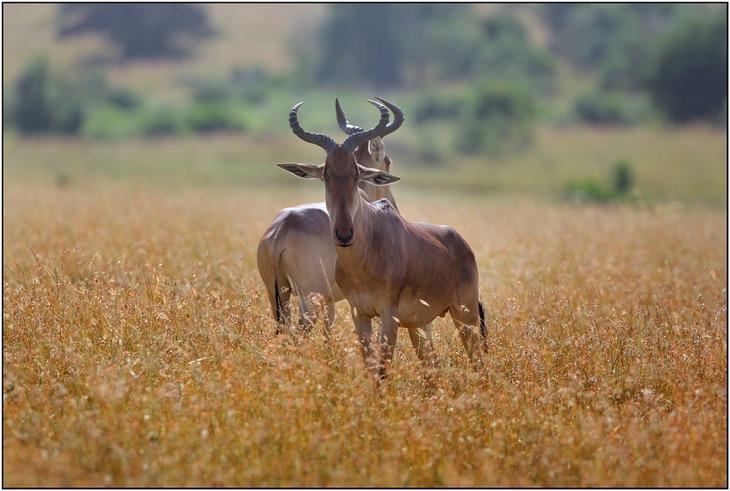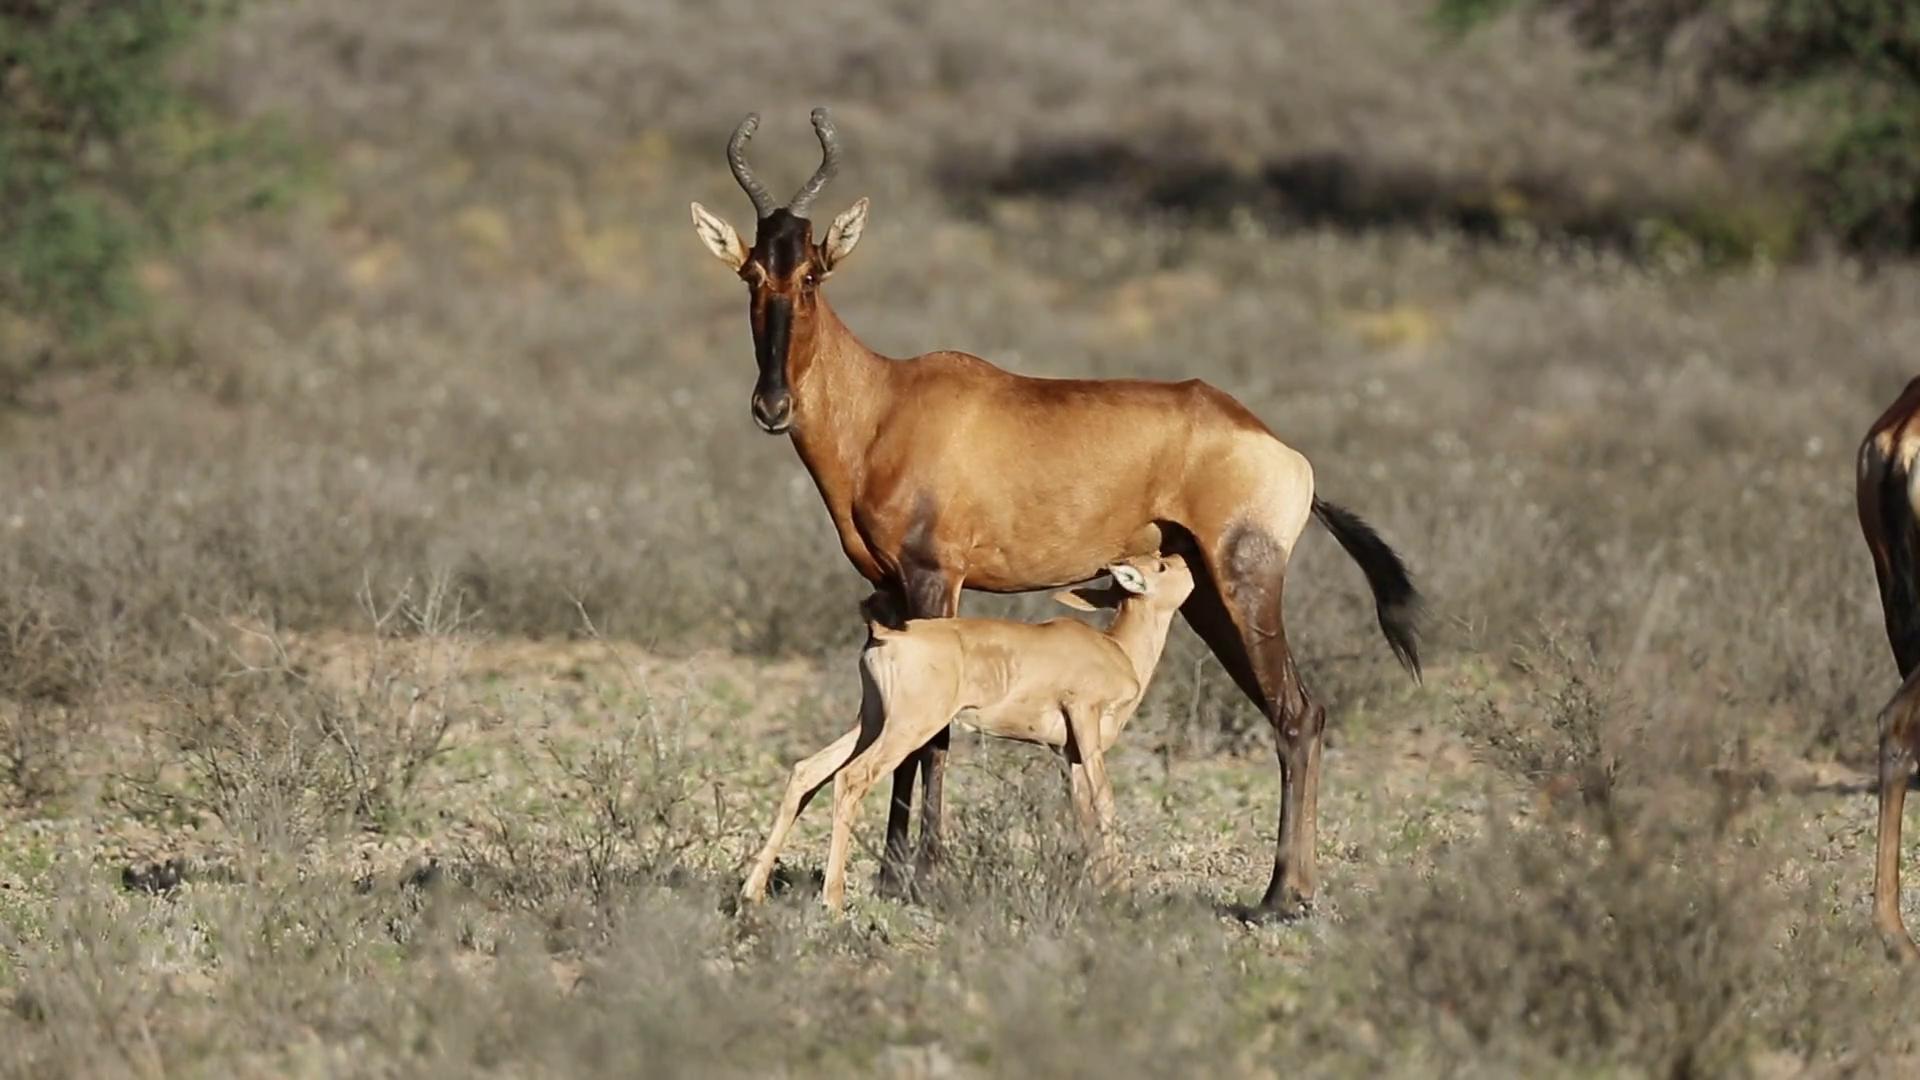The first image is the image on the left, the second image is the image on the right. Evaluate the accuracy of this statement regarding the images: "One of the images shows a mommy and a baby animal together, but not touching.". Is it true? Answer yes or no. No. The first image is the image on the left, the second image is the image on the right. Assess this claim about the two images: "Exactly two animals are standing.". Correct or not? Answer yes or no. No. 